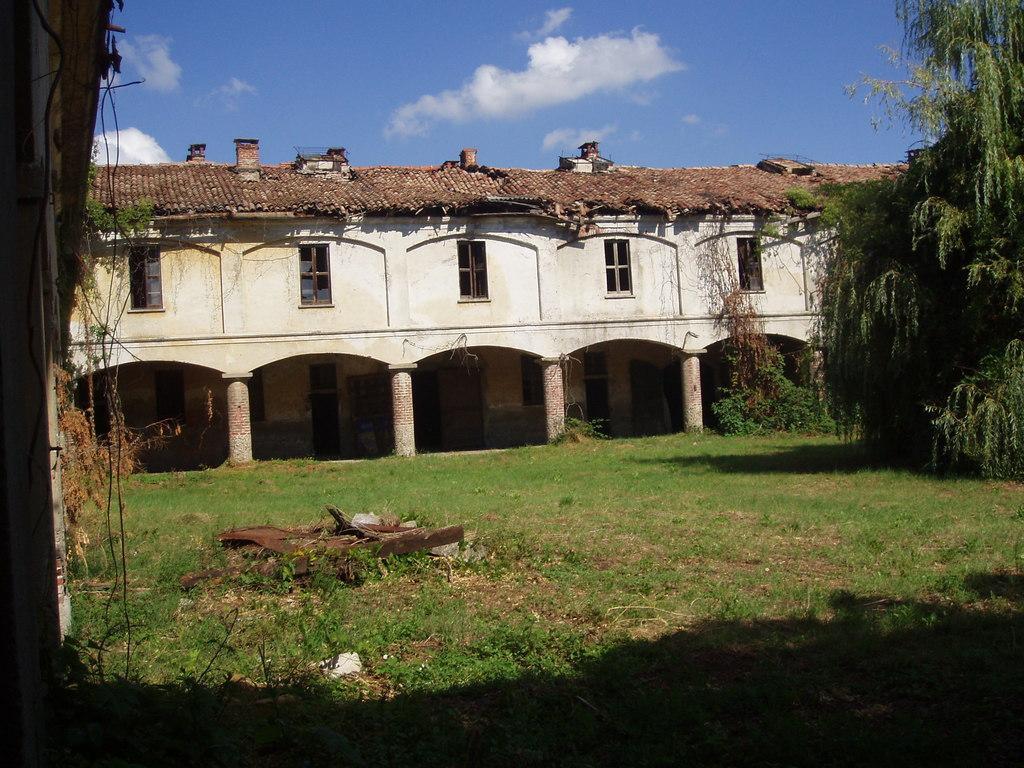How would you summarize this image in a sentence or two? In this image we can see a building, trees, ground, creepers and sky with clouds. 